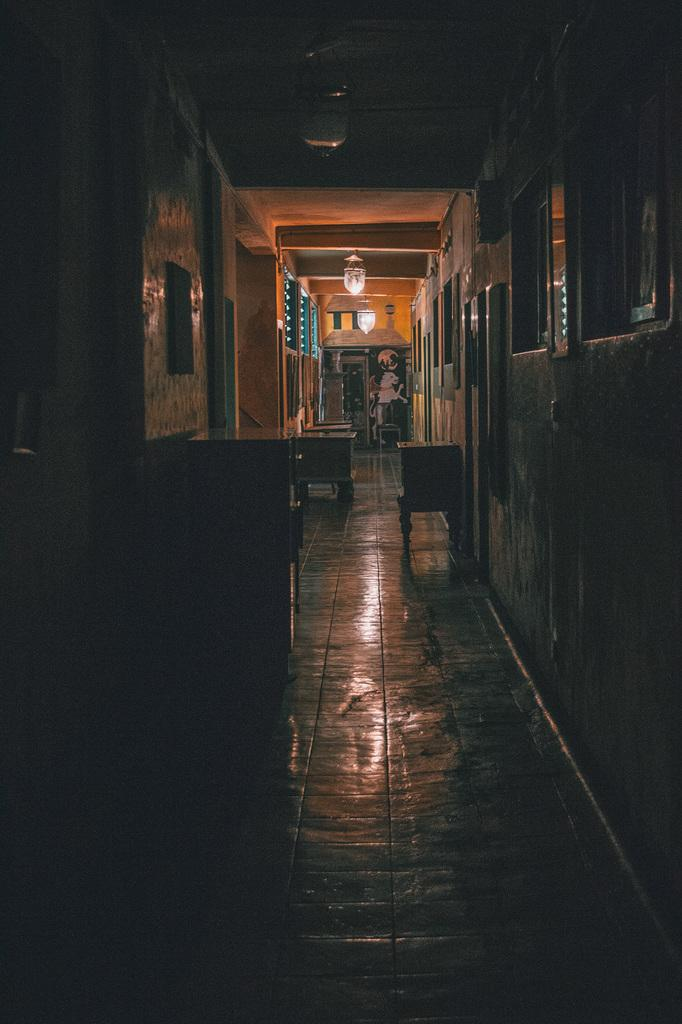What type of space is depicted in the image? There is a corridor in the image. What can be found in the corridor? There are stands in the corridor. What is visible in the background of the image? There is a wall in the background of the image. What can be seen illuminating the corridor? Lights are visible in the image. What is placed on the wall in the image? There are frames placed on the wall. Can you tell me how many friends are visible in the image? There is no mention of friends in the image; it features a corridor with stands, lights, and frames on the wall. What is the need for the stands in the image? The purpose of the stands in the image is not specified, but they are present in the corridor. 